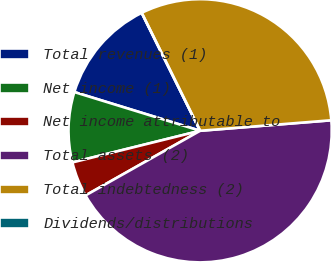Convert chart to OTSL. <chart><loc_0><loc_0><loc_500><loc_500><pie_chart><fcel>Total revenues (1)<fcel>Net income (1)<fcel>Net income attributable to<fcel>Total assets (2)<fcel>Total indebtedness (2)<fcel>Dividends/distributions<nl><fcel>12.93%<fcel>8.62%<fcel>4.31%<fcel>43.1%<fcel>31.05%<fcel>0.0%<nl></chart> 